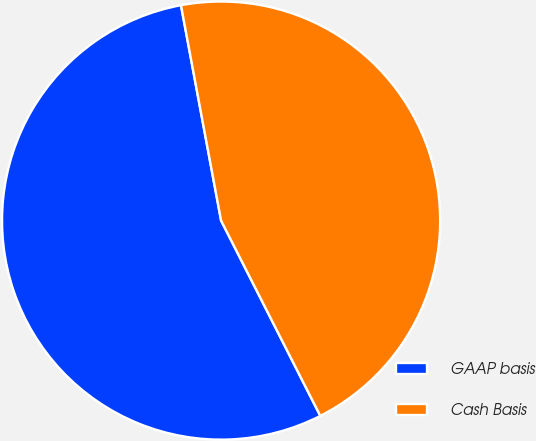Convert chart. <chart><loc_0><loc_0><loc_500><loc_500><pie_chart><fcel>GAAP basis<fcel>Cash Basis<nl><fcel>54.55%<fcel>45.45%<nl></chart> 